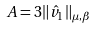<formula> <loc_0><loc_0><loc_500><loc_500>A = 3 \| { \hat { v } } _ { 1 } \| _ { \mu , \beta }</formula> 